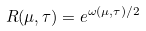Convert formula to latex. <formula><loc_0><loc_0><loc_500><loc_500>R ( \mu , \tau ) = e ^ { \omega ( \mu , \tau ) / 2 }</formula> 